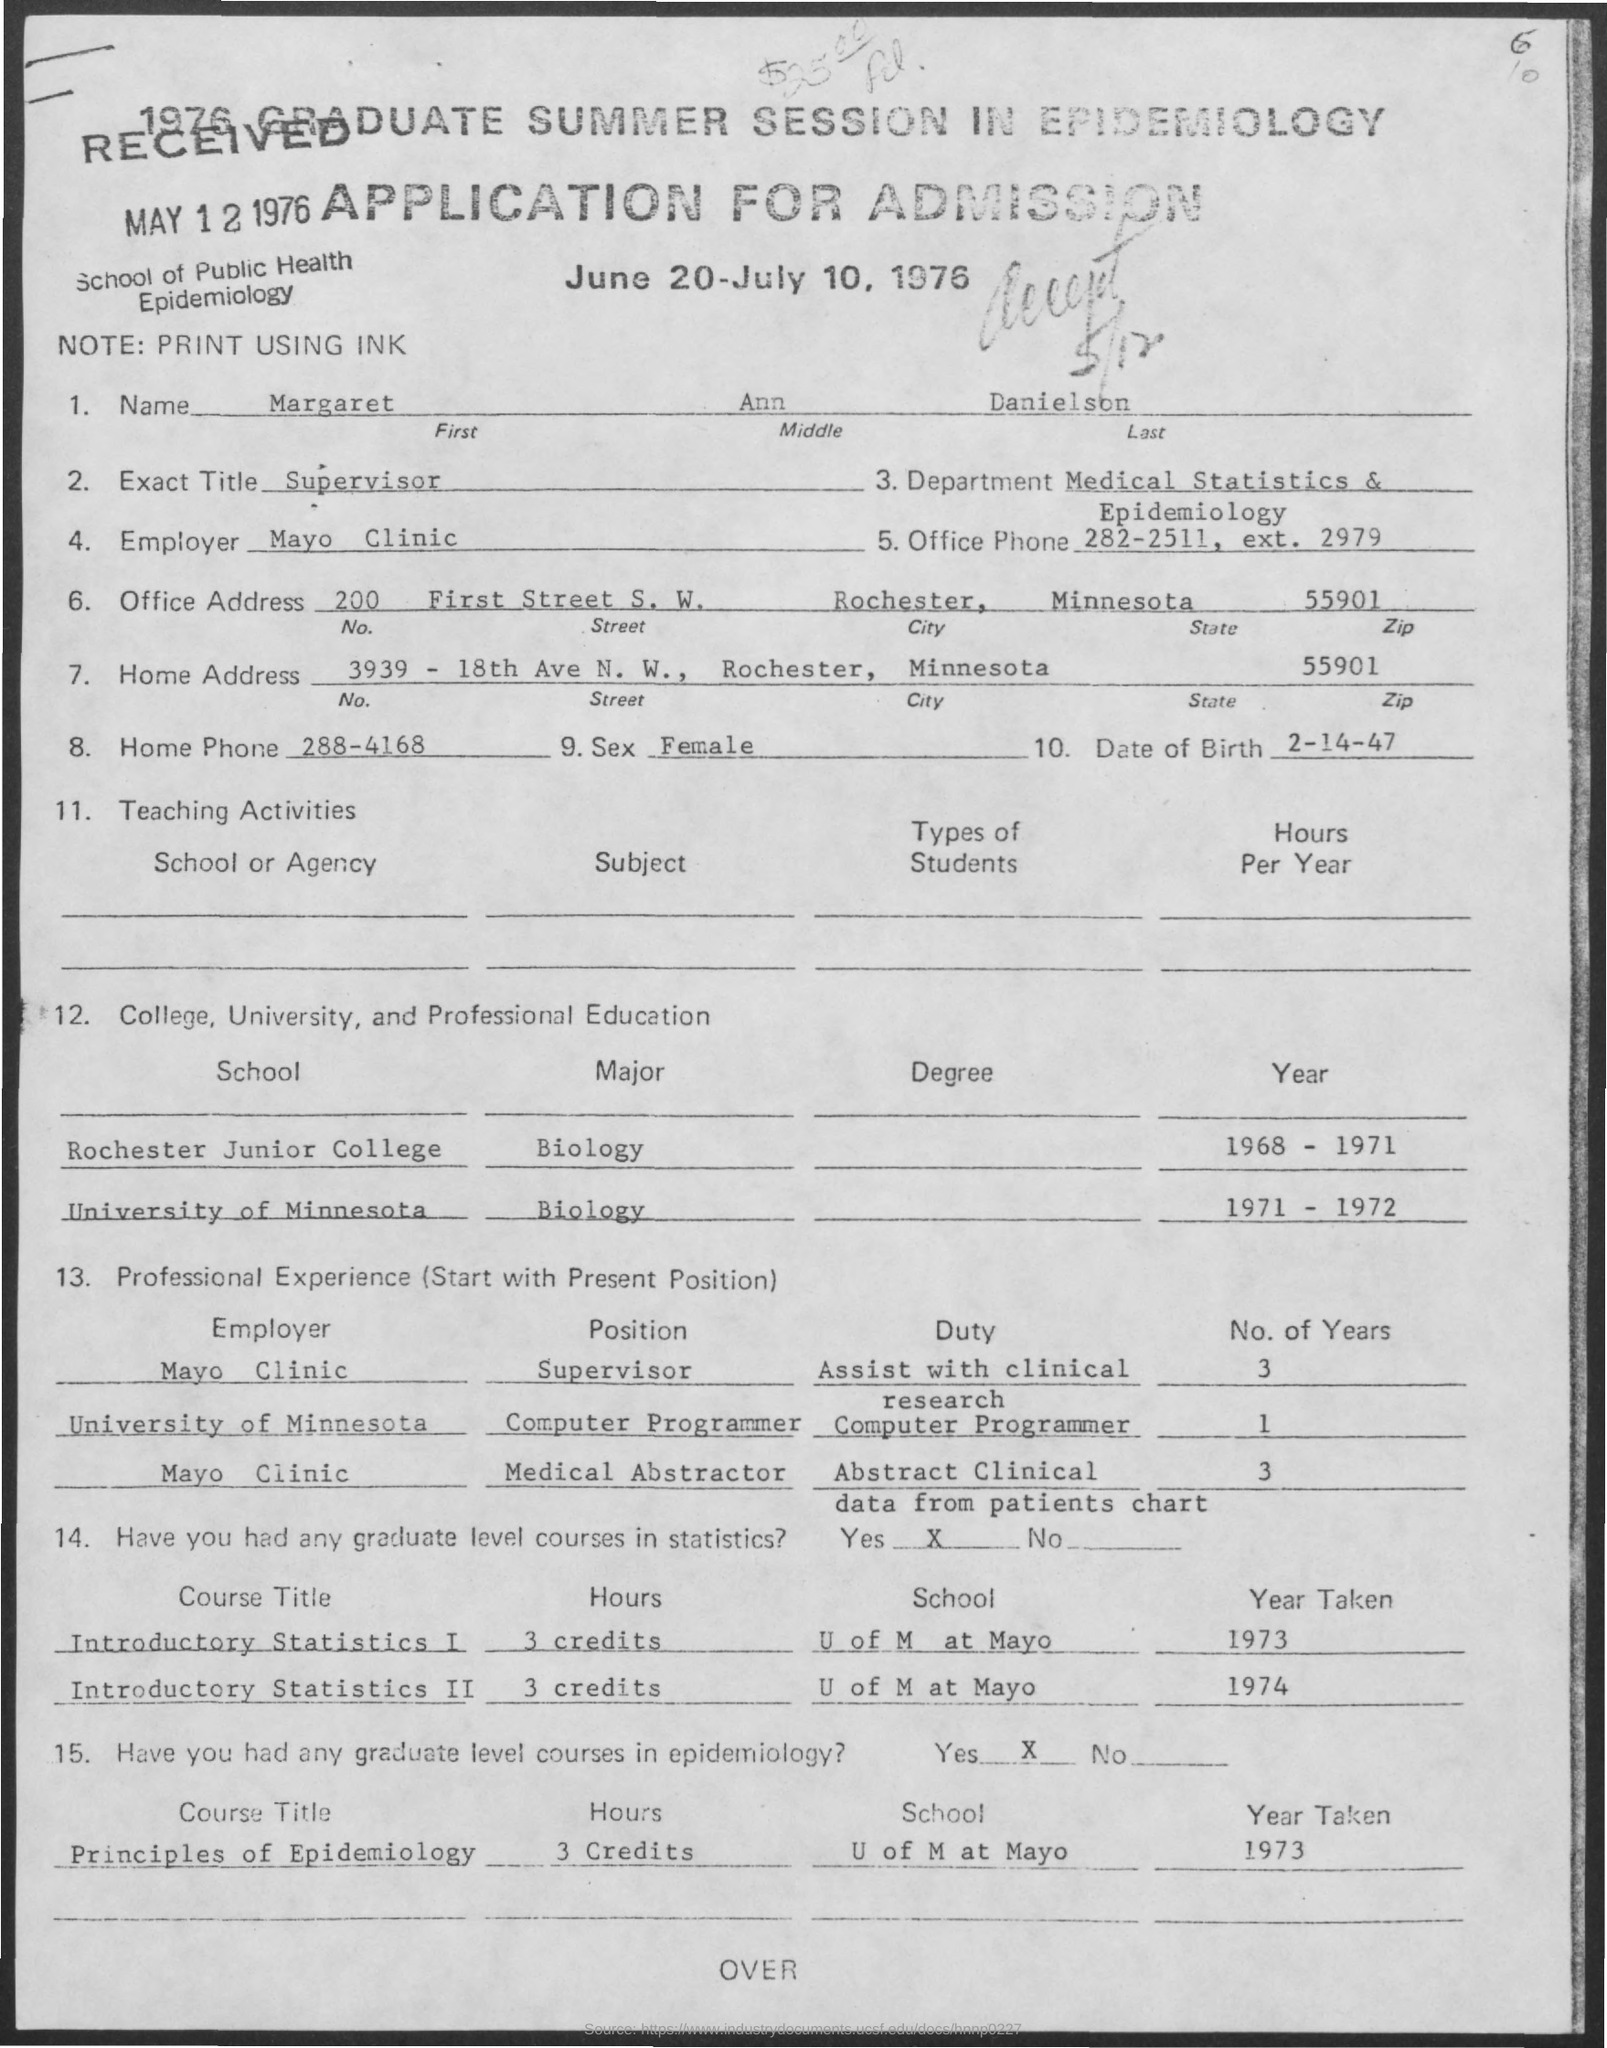What is the Name of the person given in the Application?
Offer a terse response. Margaret ann danielson. What is the Exact Title of Margaret Ann Danielson as given in the application?
Provide a short and direct response. Supervisor. What is the Home Phone no of Margaret Ann Danielson?
Provide a short and direct response. 288-4168. What is the Date of Birth of Margaret Ann Danielson?
Your answer should be compact. 2-14-47. What is the Zip code given in the home address?
Provide a short and direct response. 55901. In which clinic, Margaret Ann Danielson is employed as mentioned in the application?
Give a very brief answer. Mayo Clinic. What was the duty assigned to Margaret Ann Danielson as a supervisor in Mayoclinic?
Your answer should be very brief. Assist with clinical research. What was the duty assigned to Margaret Ann Danielson as a Medical Abstractor in Mayoclinic?
Keep it short and to the point. Abstract clinical data from patients chart. 